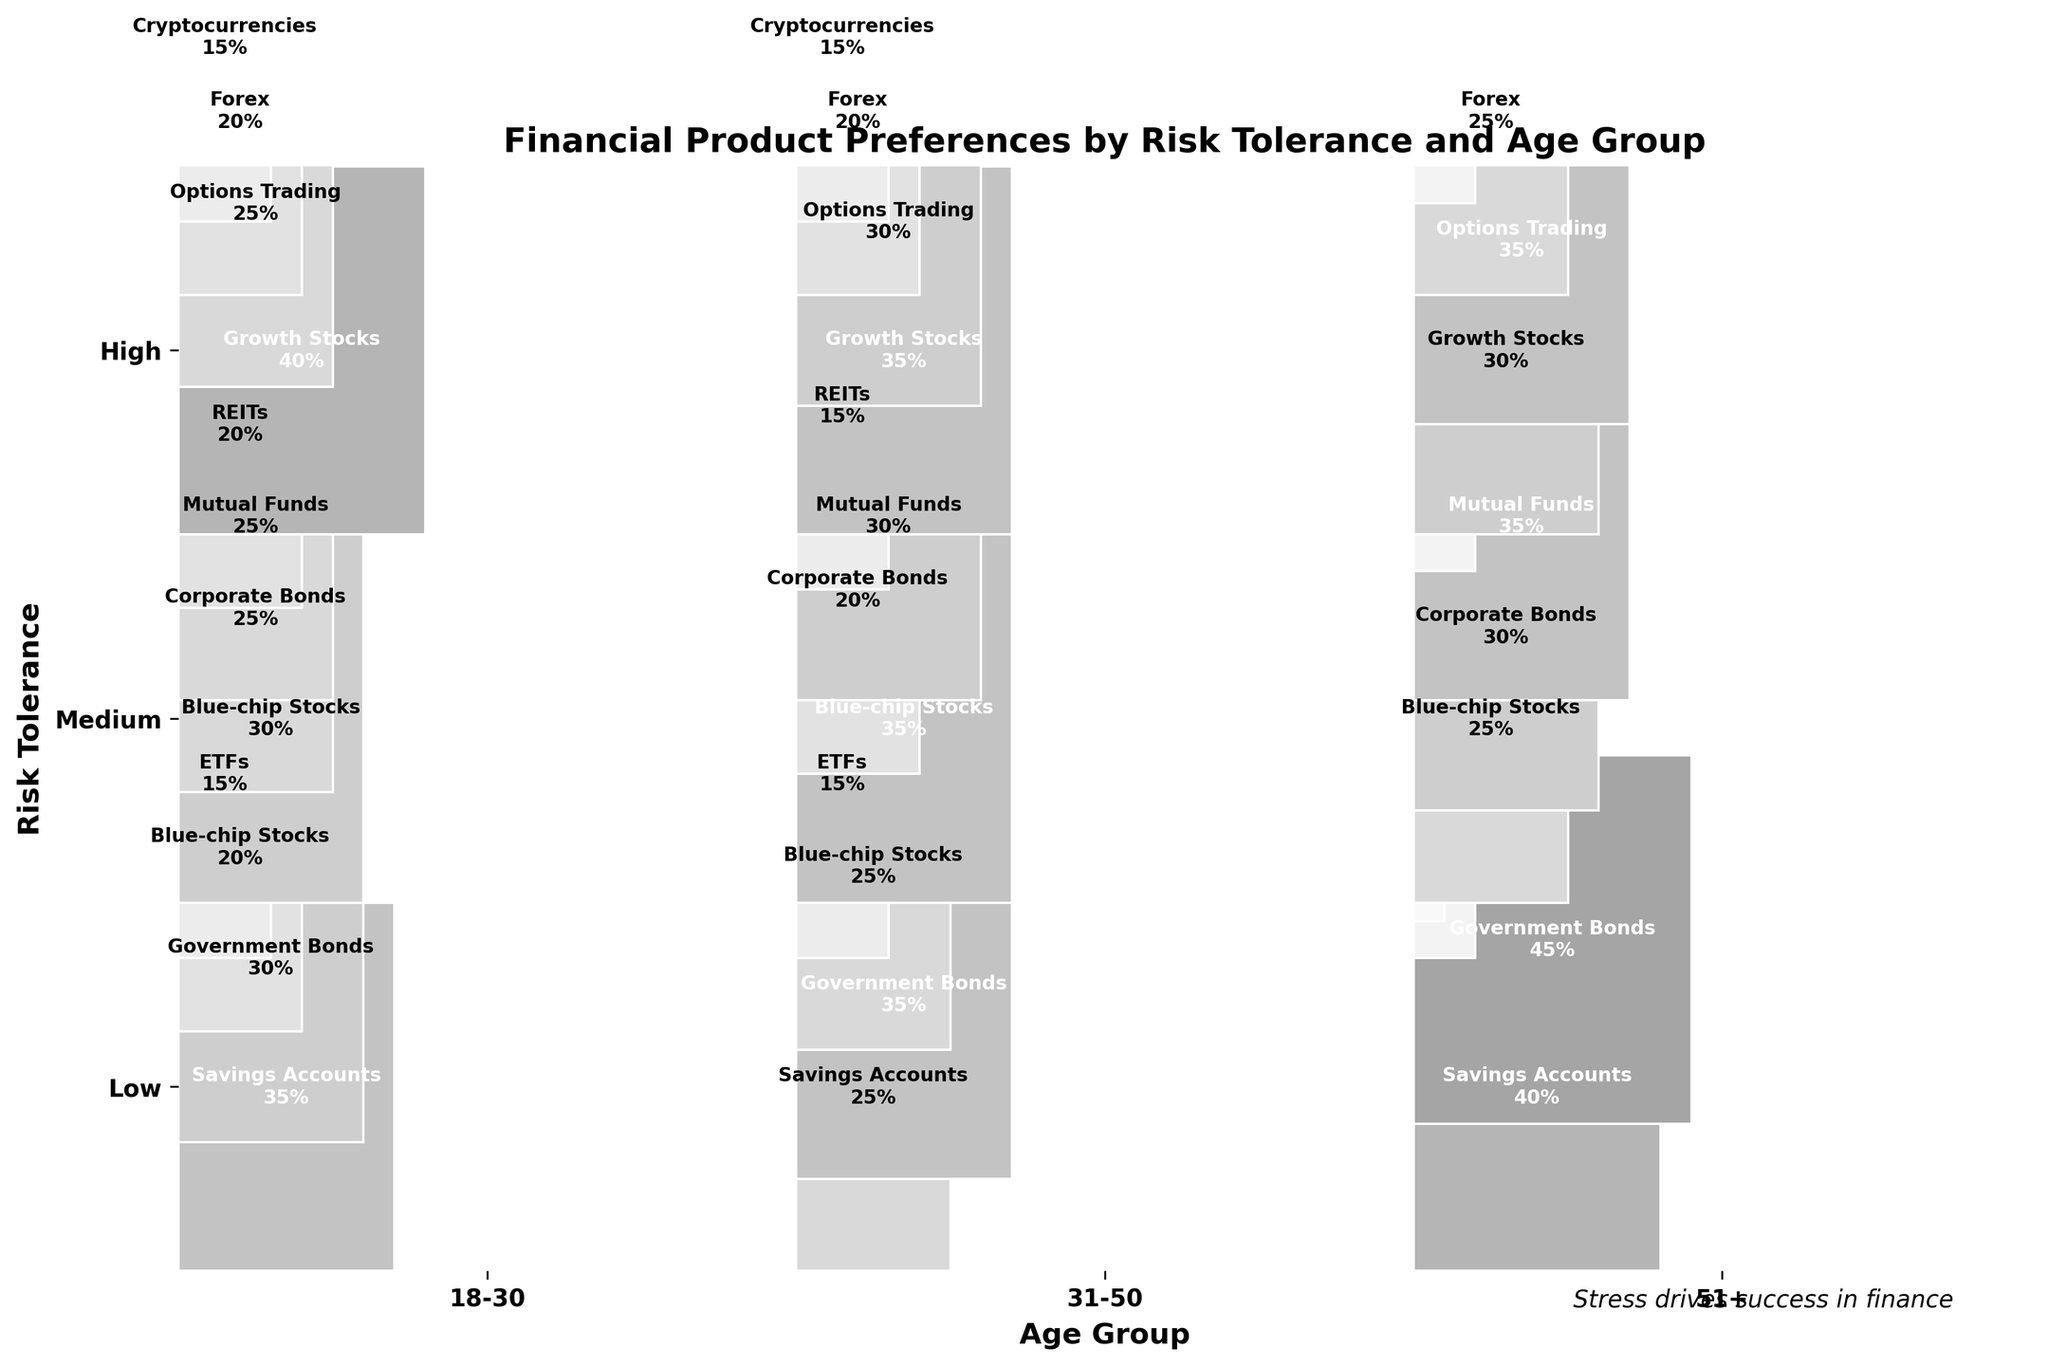What's the title of the plot? The title of the plot is located at the top of the figure and it provides a summary of what the plot represents. By reading the top of the figure, you can see the title reads "Financial Product Preferences by Risk Tolerance and Age Group."
Answer: Financial Product Preferences by Risk Tolerance and Age Group Which age group has the highest percentage of investment in Government Bonds for low risk tolerance? To find the age group with the highest percentage of investment in Government Bonds for low risk tolerance, look at the "Low" risk tolerance row. Then, compare the percentages in Government Bonds across each age group. The highest percentage in the "Low" risk tolerance row for Government Bonds is with the "51+" age group at 45%.
Answer: 51+ What is the percentage difference of investment in Blue-chip Stocks between medium and high risk tolerance for the 31-50 age group? First, find the percentage of investment in Blue-chip Stocks for medium risk tolerance in the 31-50 age group, which is 35%. Next, find the same for high risk tolerance in the same age group, which is not present. Therefore, the percentage for high risk tolerance is 0%. Subtract the high risk percentage from the medium risk percentage: 35% - 0% = 35%.
Answer: 35% Among all the financial products, which one has the highest percentage investment in the 18-30 age group with high risk tolerance? Review the "High" risk tolerance segment for the 18-30 age group. The percentages are divided among Growth Stocks (40%), Options Trading (25%), Forex (20%), and Cryptocurrencies (15%). The highest percentage is for Growth Stocks at 40%.
Answer: Growth Stocks Compare the share of Government Bonds and Mutual Funds for medium risk tolerance across all age groups. Which one has a higher average percentage? Calculate the average percentage of Government Bonds and Mutual Funds for medium risk tolerance. For Government Bonds: 18-30 (25%) + 31-50 (20%) + 51+ (30%) = 75% / 3 = 25%. For Mutual Funds: 18-30 (25%) + 31-50 (30%) + 51+ (35%) = 90% / 3 = 30%. Mutual Funds have a higher average percentage at 30% compared to 25% for Government Bonds.
Answer: Mutual Funds For low risk tolerance, which financial product category sees an increase in percentage preference as the age group increases? Observe the categories in the "Low" risk tolerance row and track their percentages as the age group transitions from 18-30, 31-50, to 51+. Government Bonds and Savings Accounts are the categories that increase in percentage preference. For Savings Accounts: 35% (18-30), 25% (31-50), 40% (51+). For Government Bonds: 30% (18-30), 35% (31-50), 45% (51+).
Answer: Government Bonds and Savings Accounts 